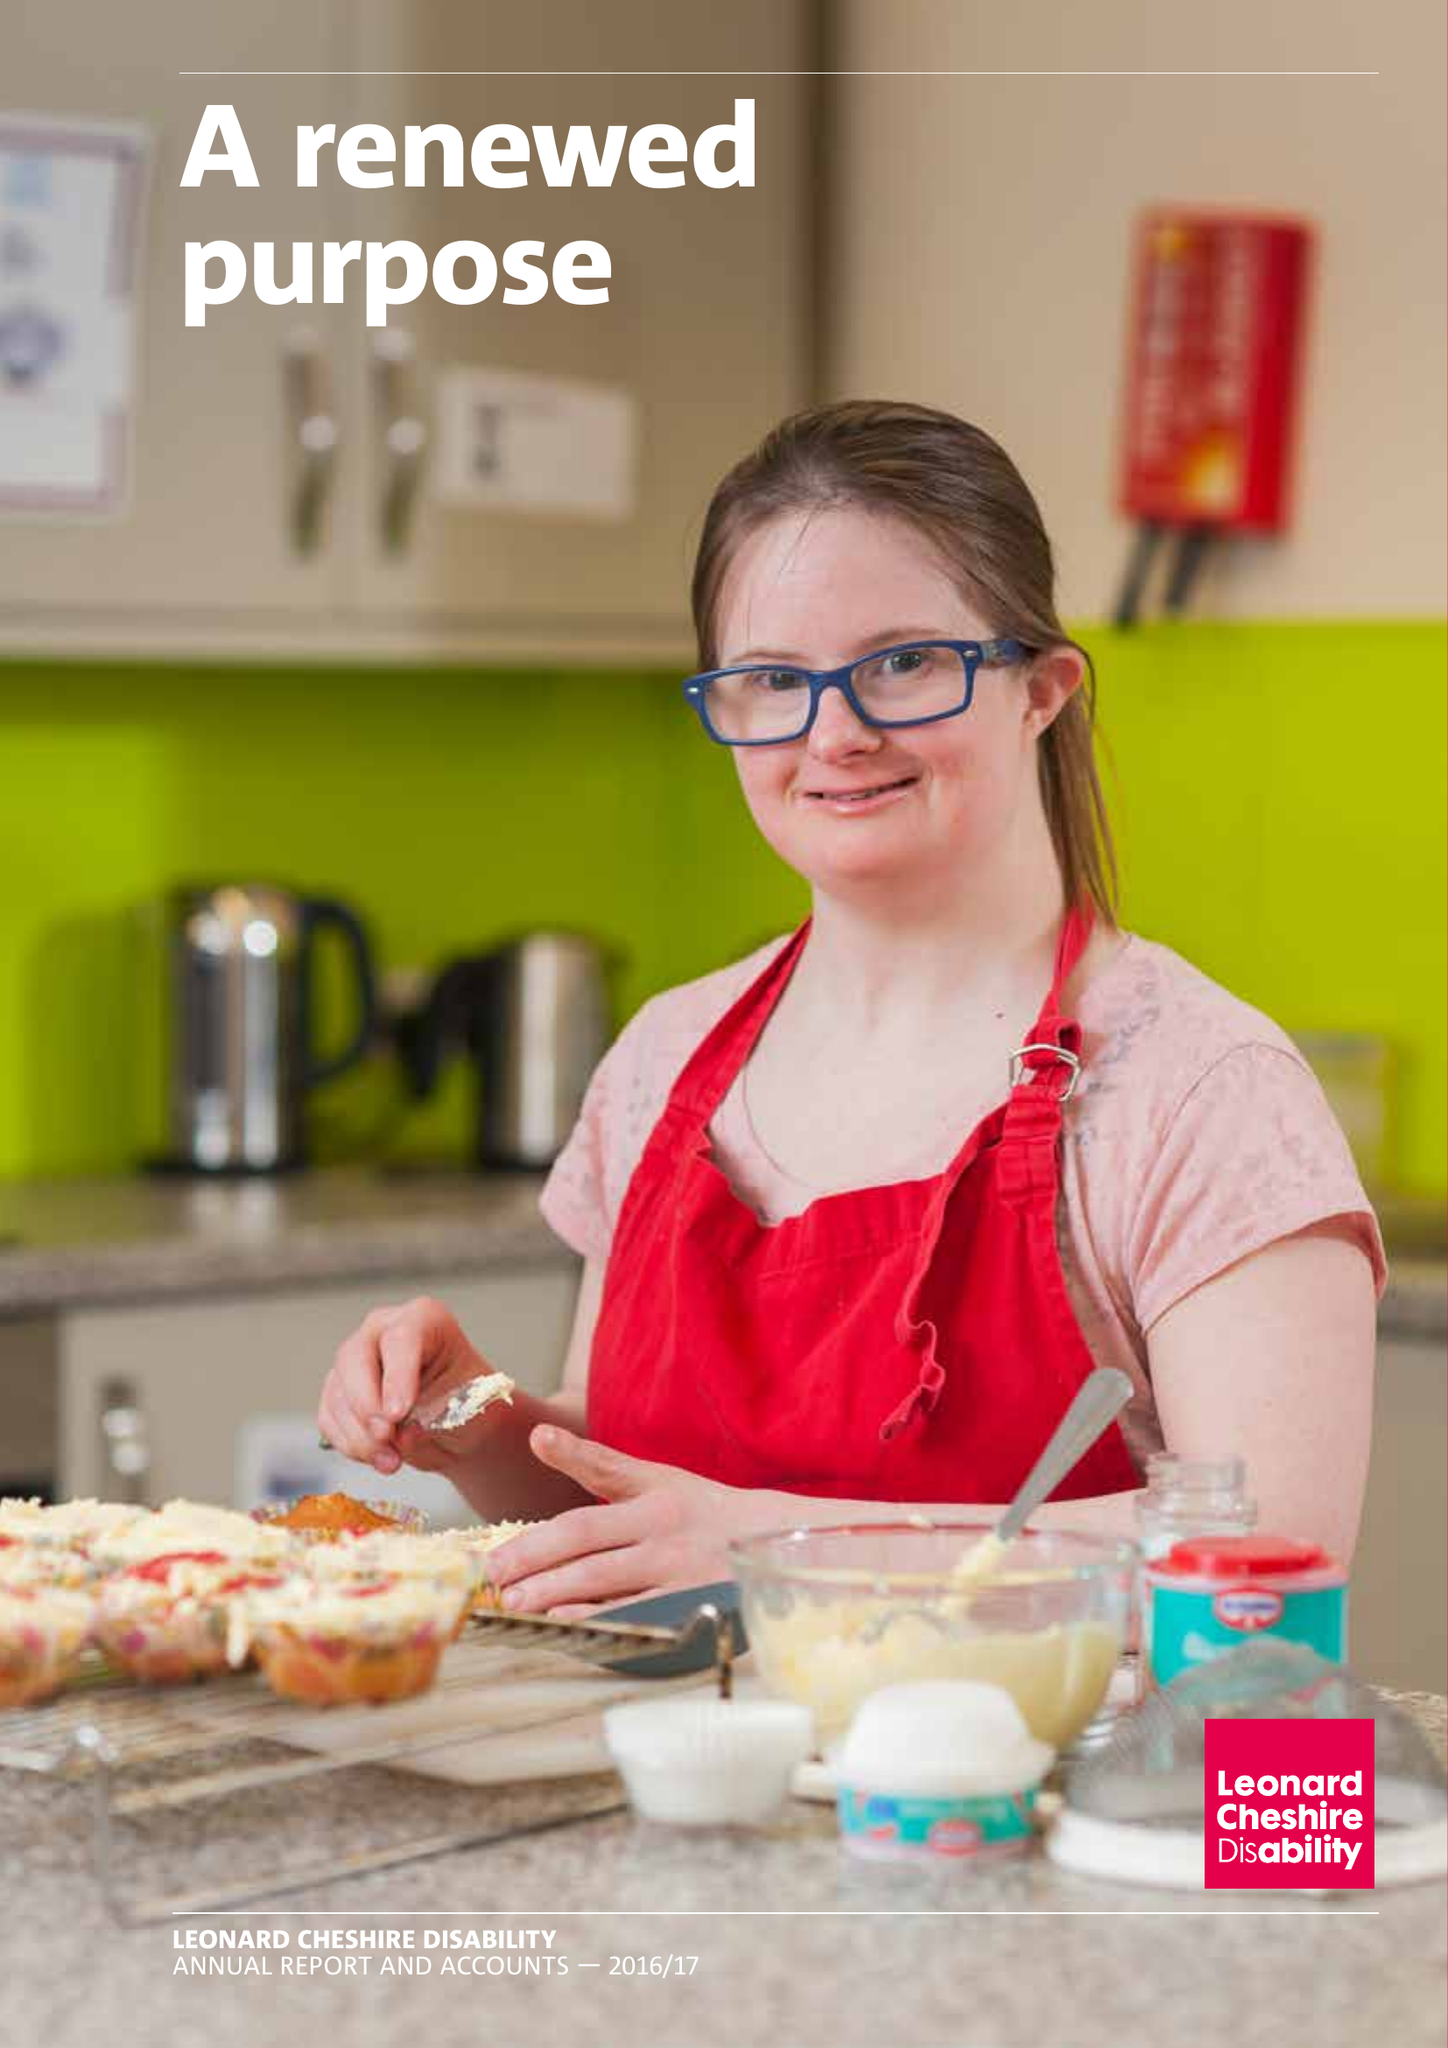What is the value for the address__post_town?
Answer the question using a single word or phrase. LONDON 